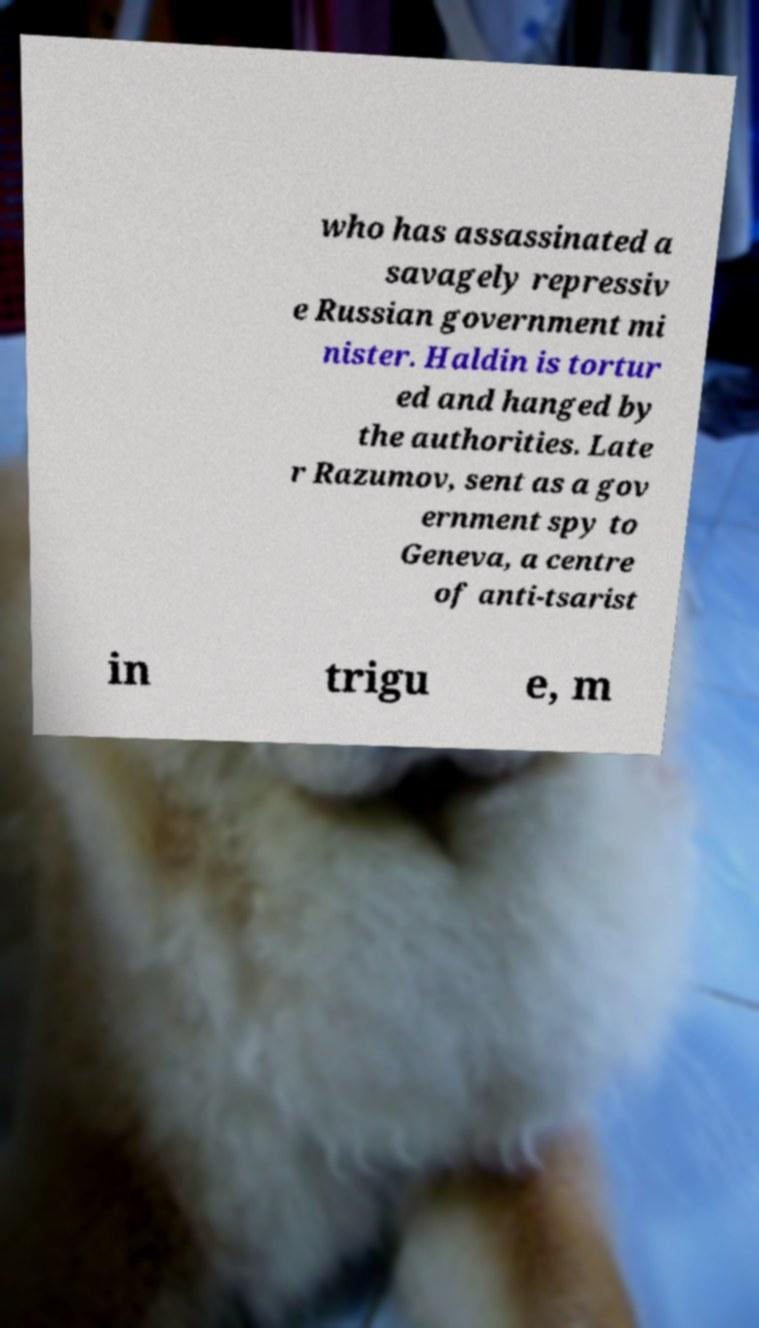Please read and relay the text visible in this image. What does it say? who has assassinated a savagely repressiv e Russian government mi nister. Haldin is tortur ed and hanged by the authorities. Late r Razumov, sent as a gov ernment spy to Geneva, a centre of anti-tsarist in trigu e, m 